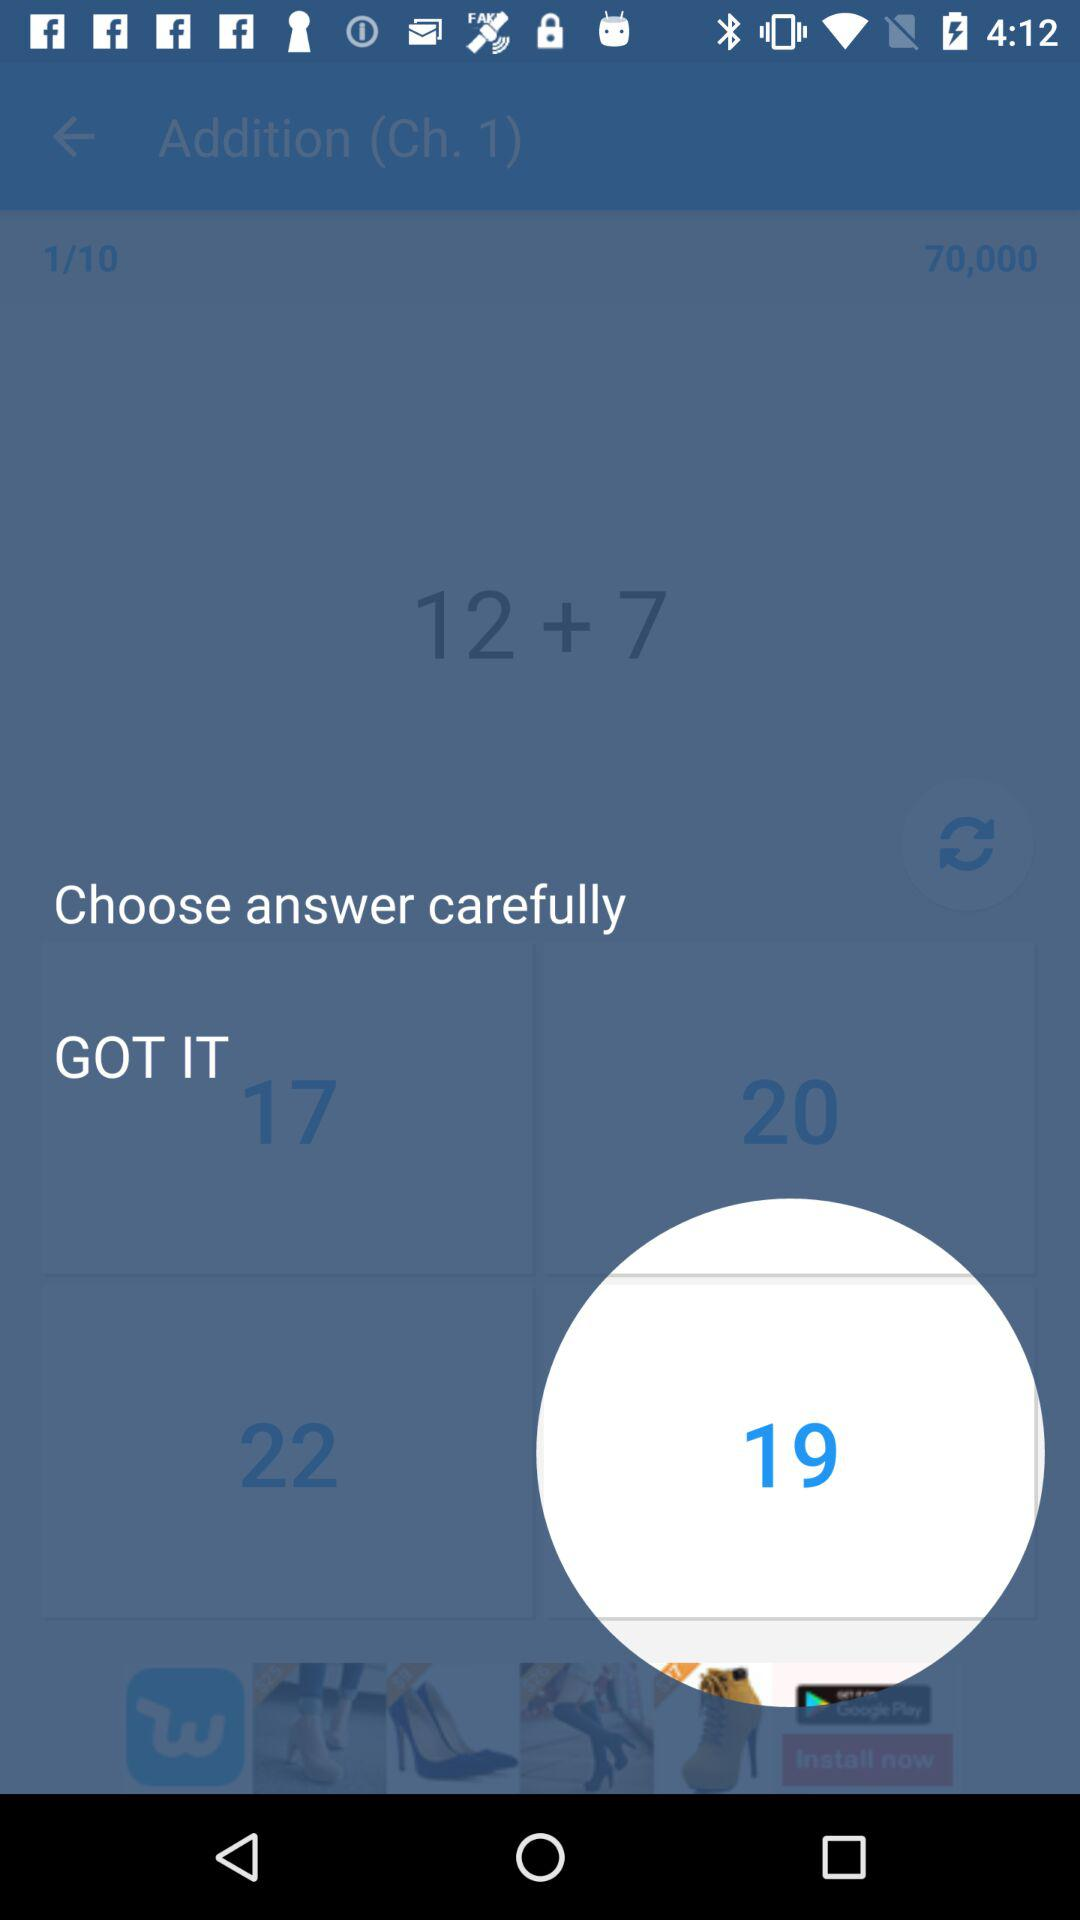What is the sum of 12 + 7?
Answer the question using a single word or phrase. 19 